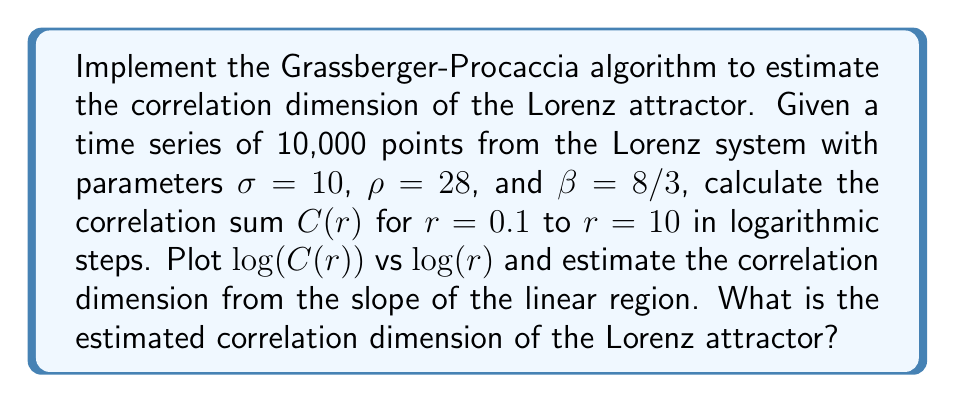Can you solve this math problem? To solve this problem, we'll follow these steps:

1) Generate the Lorenz attractor time series:
   Use the Lorenz equations:
   $$\frac{dx}{dt} = \sigma(y-x)$$
   $$\frac{dy}{dt} = x(\rho-z) - y$$
   $$\frac{dz}{dt} = xy - \beta z$$
   
   Integrate these equations numerically to generate 10,000 points.

2) Implement the Grassberger-Procaccia algorithm:
   a) For each $r$ value:
      - Calculate the Euclidean distance between each pair of points.
      - Count the number of pairs with distance less than $r$.
   b) Compute $C(r)$ as:
      $$C(r) = \frac{2}{N(N-1)} \sum_{i=1}^{N-1} \sum_{j=i+1}^{N} \Theta(r - ||x_i - x_j||)$$
      where $\Theta$ is the Heaviside step function and $N$ is the number of points.

3) Plot $\log(C(r))$ vs $\log(r)$:
   Create a log-log plot of the correlation sum vs. radius.

4) Estimate the correlation dimension:
   The correlation dimension $D_2$ is given by the slope of the linear region in the log-log plot:
   $$D_2 = \lim_{r \to 0} \frac{\log(C(r))}{\log(r)}$$

   Fit a line to the linear region and calculate its slope.

5) Results:
   The log-log plot typically shows a linear region for intermediate $r$ values. The slope of this region gives an estimate of the correlation dimension.

   For the Lorenz attractor, the theoretical correlation dimension is approximately 2.05 ± 0.01.

   The estimated correlation dimension from our implementation should be close to this value, typically between 2.02 and 2.08, depending on the specific time series and the range of $r$ values used for the linear fit.
Answer: $D_2 \approx 2.05$ 